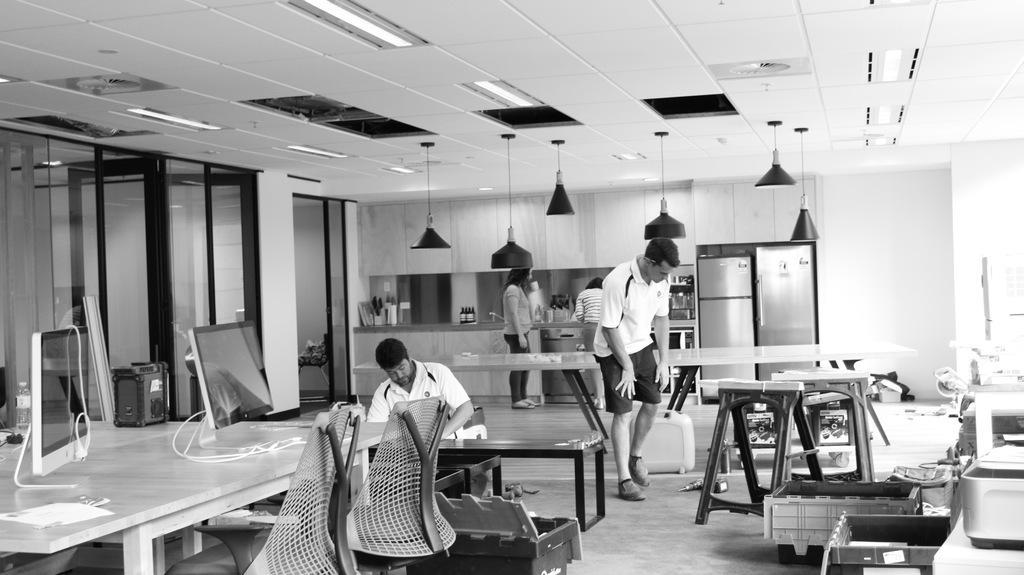Describe this image in one or two sentences. This is the picture inside of the room. There is a person sitting behind the table other persons are standing. There are computers, wires on the table. At the back there is a door. At the top there are lights and at the right side of the image there are devices. At the front there are two chairs, at the back there are two refrigerators, there are bottles on the desk. 